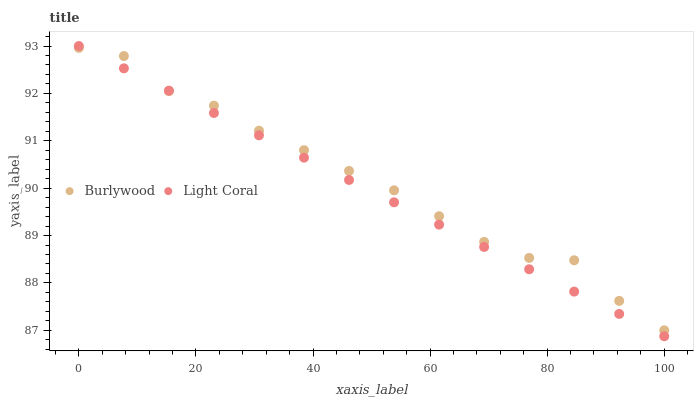Does Light Coral have the minimum area under the curve?
Answer yes or no. Yes. Does Burlywood have the maximum area under the curve?
Answer yes or no. Yes. Does Light Coral have the maximum area under the curve?
Answer yes or no. No. Is Light Coral the smoothest?
Answer yes or no. Yes. Is Burlywood the roughest?
Answer yes or no. Yes. Is Light Coral the roughest?
Answer yes or no. No. Does Light Coral have the lowest value?
Answer yes or no. Yes. Does Light Coral have the highest value?
Answer yes or no. Yes. Does Light Coral intersect Burlywood?
Answer yes or no. Yes. Is Light Coral less than Burlywood?
Answer yes or no. No. Is Light Coral greater than Burlywood?
Answer yes or no. No. 